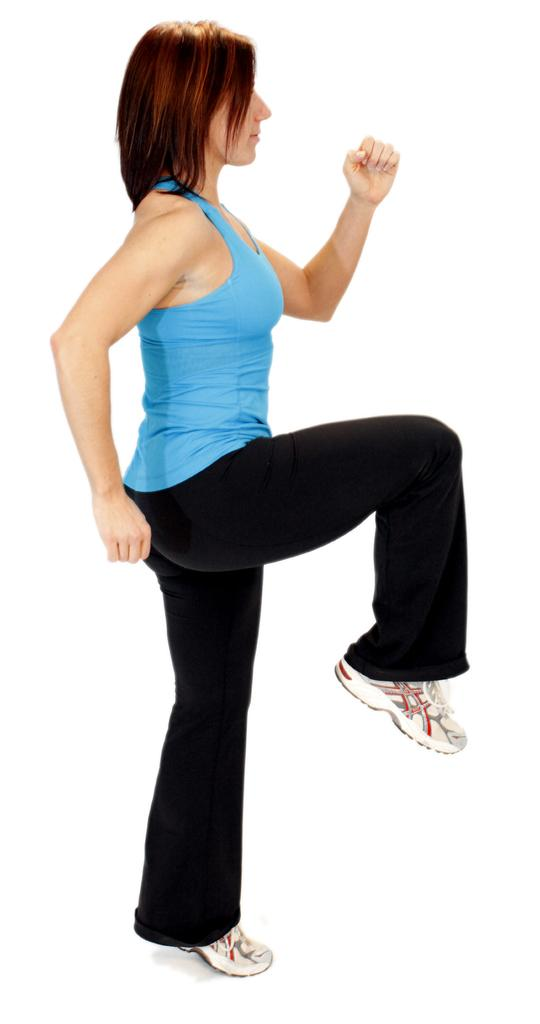What is the main subject of the image? There is a person in the image. What is the person wearing in the image? The person is wearing a blue and black color dress and shoes. What is the color of the background in the image? The background of the image is white. Can you see a kitten playing with a star in the image? There is no kitten or star present in the image. Is there any magic happening in the image? There is no indication of magic in the image; it simply shows a person wearing a blue and black dress with a white background. 